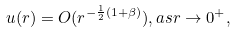Convert formula to latex. <formula><loc_0><loc_0><loc_500><loc_500>u ( r ) = O ( r ^ { - \frac { 1 } { 2 } ( 1 + \beta ) } ) , a s r \to 0 ^ { + } ,</formula> 